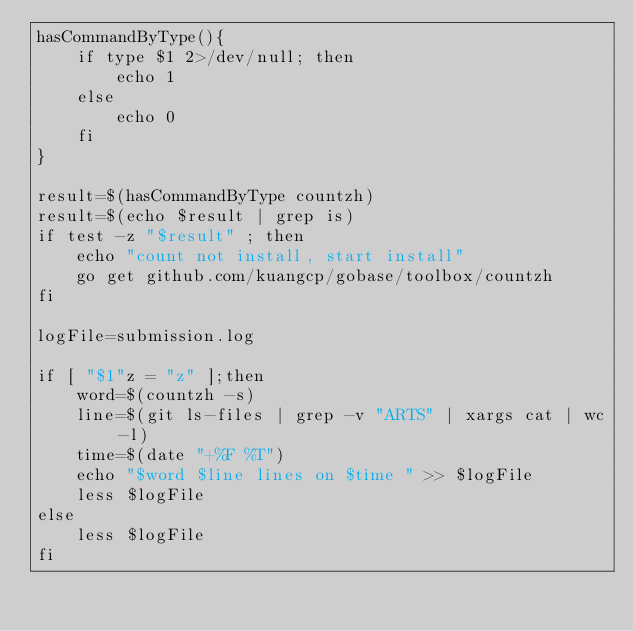<code> <loc_0><loc_0><loc_500><loc_500><_Bash_>hasCommandByType(){
    if type $1 2>/dev/null; then
        echo 1
    else 
        echo 0
    fi
}

result=$(hasCommandByType countzh)
result=$(echo $result | grep is)
if test -z "$result" ; then
    echo "count not install, start install"
    go get github.com/kuangcp/gobase/toolbox/countzh
fi

logFile=submission.log

if [ "$1"z = "z" ];then
    word=$(countzh -s) 
    line=$(git ls-files | grep -v "ARTS" | xargs cat | wc -l)
    time=$(date "+%F %T")
    echo "$word $line lines on $time " >> $logFile
	less $logFile
else 
	less $logFile
fi
</code> 